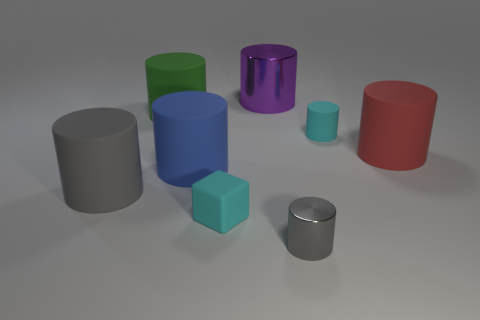Are there an equal number of red matte cylinders that are in front of the cyan rubber cube and large shiny cylinders behind the purple metal thing?
Offer a terse response. Yes. There is a big shiny thing that is behind the large red cylinder; is it the same shape as the big red rubber object?
Provide a short and direct response. Yes. Are there any other things that are made of the same material as the cyan cube?
Ensure brevity in your answer.  Yes. Do the red thing and the metallic cylinder that is to the right of the purple metal thing have the same size?
Give a very brief answer. No. What number of other things are the same color as the large shiny object?
Keep it short and to the point. 0. There is a small gray metal cylinder; are there any large purple cylinders in front of it?
Make the answer very short. No. How many things are small matte things or metal things behind the large green cylinder?
Ensure brevity in your answer.  3. There is a metal thing that is to the left of the tiny shiny thing; are there any cylinders behind it?
Make the answer very short. No. What is the shape of the large matte object that is behind the tiny cyan matte thing that is behind the tiny rubber thing that is left of the big shiny cylinder?
Make the answer very short. Cylinder. The cylinder that is in front of the large blue rubber cylinder and behind the rubber block is what color?
Give a very brief answer. Gray. 